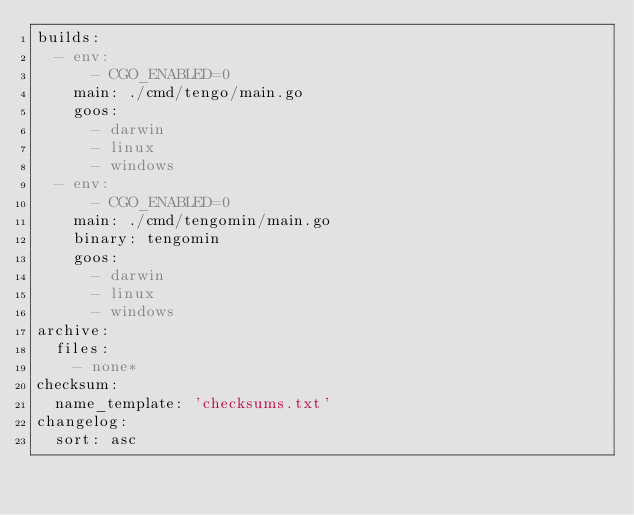<code> <loc_0><loc_0><loc_500><loc_500><_YAML_>builds:
  - env:
      - CGO_ENABLED=0
    main: ./cmd/tengo/main.go
    goos:
      - darwin
      - linux
      - windows
  - env:
      - CGO_ENABLED=0
    main: ./cmd/tengomin/main.go
    binary: tengomin
    goos:
      - darwin
      - linux
      - windows
archive:
  files:
    - none*
checksum:
  name_template: 'checksums.txt'
changelog:
  sort: asc
</code> 